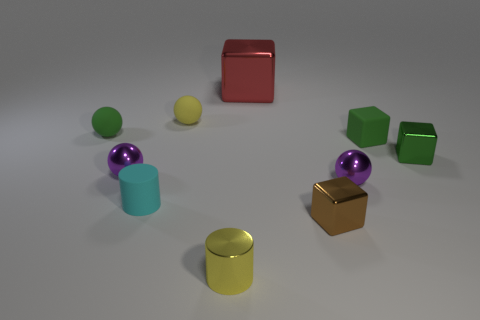Are there an equal number of small purple shiny balls that are right of the small cyan matte cylinder and tiny cyan matte cylinders?
Ensure brevity in your answer.  Yes. Are there any shiny spheres of the same size as the brown metal object?
Your answer should be compact. Yes. Does the green matte block have the same size as the metal thing behind the green metallic thing?
Ensure brevity in your answer.  No. Are there an equal number of yellow spheres on the right side of the cyan matte thing and large cubes in front of the tiny brown shiny block?
Your answer should be compact. No. What is the shape of the rubber object that is the same color as the matte block?
Give a very brief answer. Sphere. There is a tiny purple sphere that is right of the matte cylinder; what material is it?
Ensure brevity in your answer.  Metal. Is the cyan cylinder the same size as the yellow metal object?
Offer a very short reply. Yes. Is the number of big red objects that are in front of the tiny yellow shiny cylinder greater than the number of tiny green rubber balls?
Offer a very short reply. No. The red block that is made of the same material as the small yellow cylinder is what size?
Your answer should be very brief. Large. Are there any large shiny objects behind the matte cylinder?
Give a very brief answer. Yes. 